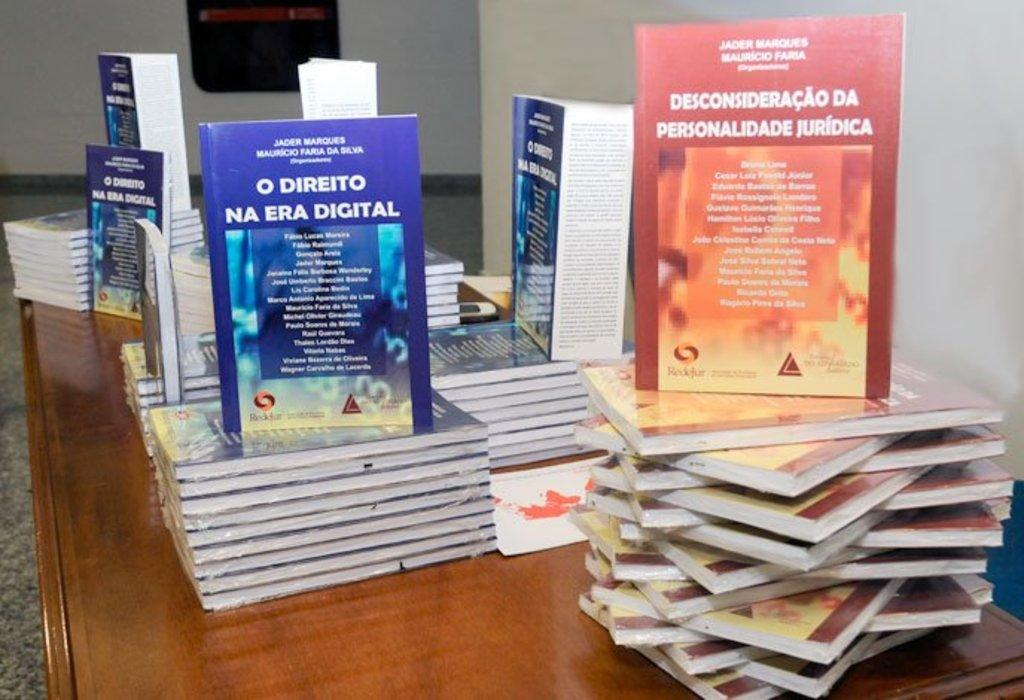<image>
Provide a brief description of the given image. Table with books including one called O Direito Na Era Digital 